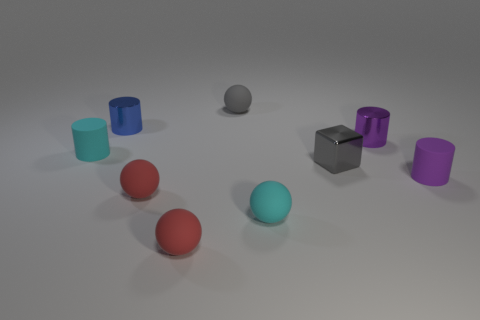How many other objects are there of the same shape as the blue metal object?
Provide a short and direct response. 3. There is a blue object that is made of the same material as the small block; what shape is it?
Offer a terse response. Cylinder. Is there a small metallic cylinder?
Provide a succinct answer. Yes. Are there fewer shiny blocks behind the small purple metal object than cyan cylinders to the left of the purple matte object?
Make the answer very short. Yes. There is a cyan object that is to the right of the gray matte thing; what is its shape?
Your answer should be compact. Sphere. Is the small block made of the same material as the tiny cyan ball?
Make the answer very short. No. What is the material of the cyan object that is the same shape as the small blue thing?
Your answer should be compact. Rubber. Are there fewer cyan spheres that are to the left of the tiny blue shiny cylinder than small green rubber things?
Provide a succinct answer. No. There is a small cyan matte sphere; how many matte cylinders are to the left of it?
Ensure brevity in your answer.  1. Does the small cyan object on the left side of the small blue cylinder have the same shape as the small purple rubber thing that is right of the blue shiny cylinder?
Keep it short and to the point. Yes. 